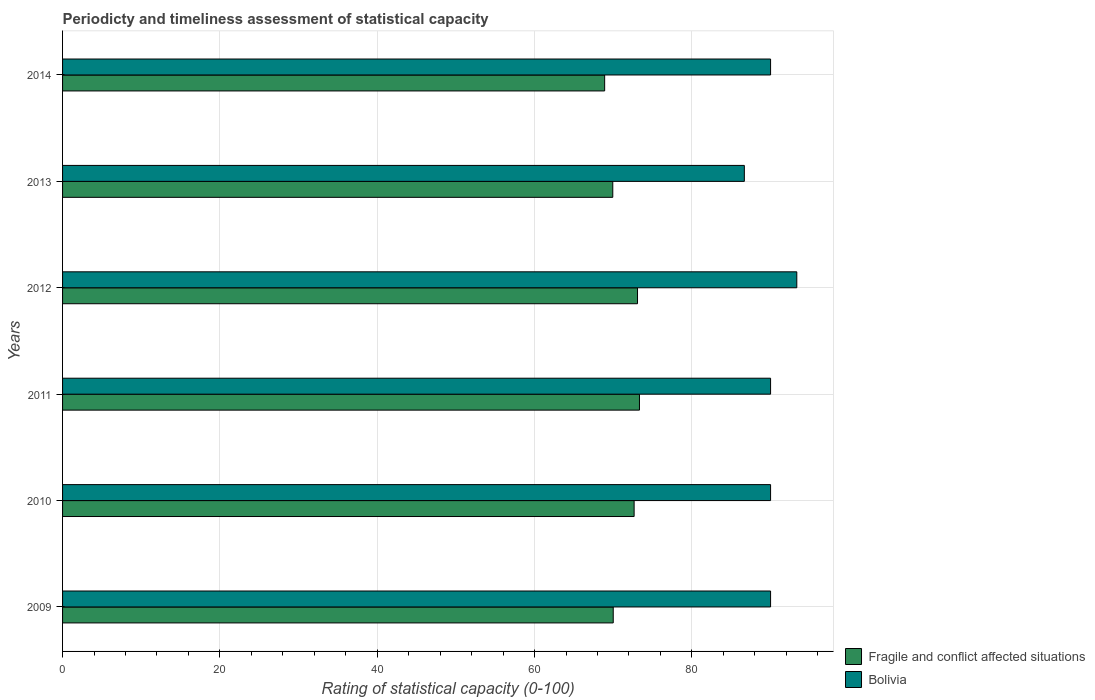How many different coloured bars are there?
Offer a terse response. 2. How many bars are there on the 5th tick from the top?
Offer a terse response. 2. What is the label of the 4th group of bars from the top?
Your response must be concise. 2011. What is the rating of statistical capacity in Fragile and conflict affected situations in 2012?
Provide a succinct answer. 73.09. Across all years, what is the maximum rating of statistical capacity in Fragile and conflict affected situations?
Offer a very short reply. 73.33. Across all years, what is the minimum rating of statistical capacity in Bolivia?
Provide a short and direct response. 86.67. What is the total rating of statistical capacity in Fragile and conflict affected situations in the graph?
Offer a very short reply. 427.92. What is the difference between the rating of statistical capacity in Bolivia in 2010 and that in 2011?
Your answer should be very brief. 0. What is the difference between the rating of statistical capacity in Bolivia in 2009 and the rating of statistical capacity in Fragile and conflict affected situations in 2014?
Offer a very short reply. 21.09. What is the average rating of statistical capacity in Bolivia per year?
Your answer should be compact. 90. In the year 2014, what is the difference between the rating of statistical capacity in Bolivia and rating of statistical capacity in Fragile and conflict affected situations?
Provide a succinct answer. 21.09. What is the ratio of the rating of statistical capacity in Fragile and conflict affected situations in 2013 to that in 2014?
Your answer should be compact. 1.02. What is the difference between the highest and the second highest rating of statistical capacity in Bolivia?
Your answer should be compact. 3.33. What is the difference between the highest and the lowest rating of statistical capacity in Bolivia?
Provide a short and direct response. 6.67. In how many years, is the rating of statistical capacity in Fragile and conflict affected situations greater than the average rating of statistical capacity in Fragile and conflict affected situations taken over all years?
Keep it short and to the point. 3. Is the sum of the rating of statistical capacity in Bolivia in 2010 and 2014 greater than the maximum rating of statistical capacity in Fragile and conflict affected situations across all years?
Your response must be concise. Yes. What does the 2nd bar from the top in 2010 represents?
Keep it short and to the point. Fragile and conflict affected situations. Are all the bars in the graph horizontal?
Offer a terse response. Yes. How many years are there in the graph?
Your response must be concise. 6. Does the graph contain any zero values?
Offer a very short reply. No. Where does the legend appear in the graph?
Your answer should be compact. Bottom right. How many legend labels are there?
Your response must be concise. 2. How are the legend labels stacked?
Your answer should be compact. Vertical. What is the title of the graph?
Offer a very short reply. Periodicty and timeliness assessment of statistical capacity. What is the label or title of the X-axis?
Your answer should be compact. Rating of statistical capacity (0-100). What is the label or title of the Y-axis?
Provide a short and direct response. Years. What is the Rating of statistical capacity (0-100) in Fragile and conflict affected situations in 2009?
Give a very brief answer. 70. What is the Rating of statistical capacity (0-100) in Bolivia in 2009?
Keep it short and to the point. 90. What is the Rating of statistical capacity (0-100) of Fragile and conflict affected situations in 2010?
Offer a terse response. 72.65. What is the Rating of statistical capacity (0-100) in Bolivia in 2010?
Make the answer very short. 90. What is the Rating of statistical capacity (0-100) in Fragile and conflict affected situations in 2011?
Your response must be concise. 73.33. What is the Rating of statistical capacity (0-100) of Bolivia in 2011?
Keep it short and to the point. 90. What is the Rating of statistical capacity (0-100) in Fragile and conflict affected situations in 2012?
Provide a succinct answer. 73.09. What is the Rating of statistical capacity (0-100) in Bolivia in 2012?
Keep it short and to the point. 93.33. What is the Rating of statistical capacity (0-100) in Fragile and conflict affected situations in 2013?
Offer a terse response. 69.94. What is the Rating of statistical capacity (0-100) in Bolivia in 2013?
Your response must be concise. 86.67. What is the Rating of statistical capacity (0-100) in Fragile and conflict affected situations in 2014?
Provide a succinct answer. 68.91. Across all years, what is the maximum Rating of statistical capacity (0-100) of Fragile and conflict affected situations?
Provide a succinct answer. 73.33. Across all years, what is the maximum Rating of statistical capacity (0-100) in Bolivia?
Provide a succinct answer. 93.33. Across all years, what is the minimum Rating of statistical capacity (0-100) in Fragile and conflict affected situations?
Keep it short and to the point. 68.91. Across all years, what is the minimum Rating of statistical capacity (0-100) of Bolivia?
Provide a short and direct response. 86.67. What is the total Rating of statistical capacity (0-100) in Fragile and conflict affected situations in the graph?
Provide a short and direct response. 427.92. What is the total Rating of statistical capacity (0-100) in Bolivia in the graph?
Your answer should be very brief. 540. What is the difference between the Rating of statistical capacity (0-100) in Fragile and conflict affected situations in 2009 and that in 2010?
Provide a succinct answer. -2.65. What is the difference between the Rating of statistical capacity (0-100) of Bolivia in 2009 and that in 2010?
Make the answer very short. 0. What is the difference between the Rating of statistical capacity (0-100) of Fragile and conflict affected situations in 2009 and that in 2012?
Your response must be concise. -3.09. What is the difference between the Rating of statistical capacity (0-100) in Fragile and conflict affected situations in 2009 and that in 2013?
Your answer should be very brief. 0.06. What is the difference between the Rating of statistical capacity (0-100) in Bolivia in 2009 and that in 2013?
Offer a very short reply. 3.33. What is the difference between the Rating of statistical capacity (0-100) of Fragile and conflict affected situations in 2009 and that in 2014?
Keep it short and to the point. 1.09. What is the difference between the Rating of statistical capacity (0-100) of Bolivia in 2009 and that in 2014?
Make the answer very short. 0. What is the difference between the Rating of statistical capacity (0-100) of Fragile and conflict affected situations in 2010 and that in 2011?
Give a very brief answer. -0.68. What is the difference between the Rating of statistical capacity (0-100) in Bolivia in 2010 and that in 2011?
Your response must be concise. 0. What is the difference between the Rating of statistical capacity (0-100) of Fragile and conflict affected situations in 2010 and that in 2012?
Keep it short and to the point. -0.43. What is the difference between the Rating of statistical capacity (0-100) of Fragile and conflict affected situations in 2010 and that in 2013?
Your answer should be very brief. 2.71. What is the difference between the Rating of statistical capacity (0-100) of Fragile and conflict affected situations in 2010 and that in 2014?
Offer a very short reply. 3.75. What is the difference between the Rating of statistical capacity (0-100) of Fragile and conflict affected situations in 2011 and that in 2012?
Your response must be concise. 0.25. What is the difference between the Rating of statistical capacity (0-100) of Bolivia in 2011 and that in 2012?
Make the answer very short. -3.33. What is the difference between the Rating of statistical capacity (0-100) of Fragile and conflict affected situations in 2011 and that in 2013?
Make the answer very short. 3.39. What is the difference between the Rating of statistical capacity (0-100) in Bolivia in 2011 and that in 2013?
Your answer should be very brief. 3.33. What is the difference between the Rating of statistical capacity (0-100) in Fragile and conflict affected situations in 2011 and that in 2014?
Keep it short and to the point. 4.43. What is the difference between the Rating of statistical capacity (0-100) in Fragile and conflict affected situations in 2012 and that in 2013?
Provide a succinct answer. 3.14. What is the difference between the Rating of statistical capacity (0-100) in Bolivia in 2012 and that in 2013?
Ensure brevity in your answer.  6.67. What is the difference between the Rating of statistical capacity (0-100) of Fragile and conflict affected situations in 2012 and that in 2014?
Make the answer very short. 4.18. What is the difference between the Rating of statistical capacity (0-100) in Bolivia in 2012 and that in 2014?
Your answer should be compact. 3.33. What is the difference between the Rating of statistical capacity (0-100) in Fragile and conflict affected situations in 2013 and that in 2014?
Offer a very short reply. 1.03. What is the difference between the Rating of statistical capacity (0-100) in Fragile and conflict affected situations in 2009 and the Rating of statistical capacity (0-100) in Bolivia in 2010?
Provide a short and direct response. -20. What is the difference between the Rating of statistical capacity (0-100) in Fragile and conflict affected situations in 2009 and the Rating of statistical capacity (0-100) in Bolivia in 2012?
Keep it short and to the point. -23.33. What is the difference between the Rating of statistical capacity (0-100) in Fragile and conflict affected situations in 2009 and the Rating of statistical capacity (0-100) in Bolivia in 2013?
Provide a succinct answer. -16.67. What is the difference between the Rating of statistical capacity (0-100) of Fragile and conflict affected situations in 2009 and the Rating of statistical capacity (0-100) of Bolivia in 2014?
Keep it short and to the point. -20. What is the difference between the Rating of statistical capacity (0-100) of Fragile and conflict affected situations in 2010 and the Rating of statistical capacity (0-100) of Bolivia in 2011?
Provide a short and direct response. -17.35. What is the difference between the Rating of statistical capacity (0-100) in Fragile and conflict affected situations in 2010 and the Rating of statistical capacity (0-100) in Bolivia in 2012?
Your response must be concise. -20.68. What is the difference between the Rating of statistical capacity (0-100) in Fragile and conflict affected situations in 2010 and the Rating of statistical capacity (0-100) in Bolivia in 2013?
Keep it short and to the point. -14.01. What is the difference between the Rating of statistical capacity (0-100) of Fragile and conflict affected situations in 2010 and the Rating of statistical capacity (0-100) of Bolivia in 2014?
Your answer should be very brief. -17.35. What is the difference between the Rating of statistical capacity (0-100) of Fragile and conflict affected situations in 2011 and the Rating of statistical capacity (0-100) of Bolivia in 2013?
Your answer should be very brief. -13.33. What is the difference between the Rating of statistical capacity (0-100) of Fragile and conflict affected situations in 2011 and the Rating of statistical capacity (0-100) of Bolivia in 2014?
Provide a succinct answer. -16.67. What is the difference between the Rating of statistical capacity (0-100) of Fragile and conflict affected situations in 2012 and the Rating of statistical capacity (0-100) of Bolivia in 2013?
Provide a short and direct response. -13.58. What is the difference between the Rating of statistical capacity (0-100) in Fragile and conflict affected situations in 2012 and the Rating of statistical capacity (0-100) in Bolivia in 2014?
Make the answer very short. -16.91. What is the difference between the Rating of statistical capacity (0-100) of Fragile and conflict affected situations in 2013 and the Rating of statistical capacity (0-100) of Bolivia in 2014?
Keep it short and to the point. -20.06. What is the average Rating of statistical capacity (0-100) of Fragile and conflict affected situations per year?
Offer a terse response. 71.32. In the year 2009, what is the difference between the Rating of statistical capacity (0-100) in Fragile and conflict affected situations and Rating of statistical capacity (0-100) in Bolivia?
Make the answer very short. -20. In the year 2010, what is the difference between the Rating of statistical capacity (0-100) of Fragile and conflict affected situations and Rating of statistical capacity (0-100) of Bolivia?
Ensure brevity in your answer.  -17.35. In the year 2011, what is the difference between the Rating of statistical capacity (0-100) of Fragile and conflict affected situations and Rating of statistical capacity (0-100) of Bolivia?
Your answer should be compact. -16.67. In the year 2012, what is the difference between the Rating of statistical capacity (0-100) in Fragile and conflict affected situations and Rating of statistical capacity (0-100) in Bolivia?
Ensure brevity in your answer.  -20.25. In the year 2013, what is the difference between the Rating of statistical capacity (0-100) in Fragile and conflict affected situations and Rating of statistical capacity (0-100) in Bolivia?
Give a very brief answer. -16.72. In the year 2014, what is the difference between the Rating of statistical capacity (0-100) of Fragile and conflict affected situations and Rating of statistical capacity (0-100) of Bolivia?
Offer a terse response. -21.09. What is the ratio of the Rating of statistical capacity (0-100) in Fragile and conflict affected situations in 2009 to that in 2010?
Your response must be concise. 0.96. What is the ratio of the Rating of statistical capacity (0-100) of Bolivia in 2009 to that in 2010?
Your response must be concise. 1. What is the ratio of the Rating of statistical capacity (0-100) of Fragile and conflict affected situations in 2009 to that in 2011?
Your response must be concise. 0.95. What is the ratio of the Rating of statistical capacity (0-100) of Fragile and conflict affected situations in 2009 to that in 2012?
Keep it short and to the point. 0.96. What is the ratio of the Rating of statistical capacity (0-100) in Bolivia in 2009 to that in 2012?
Give a very brief answer. 0.96. What is the ratio of the Rating of statistical capacity (0-100) in Fragile and conflict affected situations in 2009 to that in 2014?
Your response must be concise. 1.02. What is the ratio of the Rating of statistical capacity (0-100) in Bolivia in 2009 to that in 2014?
Offer a terse response. 1. What is the ratio of the Rating of statistical capacity (0-100) of Fragile and conflict affected situations in 2010 to that in 2011?
Keep it short and to the point. 0.99. What is the ratio of the Rating of statistical capacity (0-100) in Bolivia in 2010 to that in 2012?
Your answer should be compact. 0.96. What is the ratio of the Rating of statistical capacity (0-100) of Fragile and conflict affected situations in 2010 to that in 2013?
Your response must be concise. 1.04. What is the ratio of the Rating of statistical capacity (0-100) of Bolivia in 2010 to that in 2013?
Make the answer very short. 1.04. What is the ratio of the Rating of statistical capacity (0-100) of Fragile and conflict affected situations in 2010 to that in 2014?
Give a very brief answer. 1.05. What is the ratio of the Rating of statistical capacity (0-100) in Bolivia in 2010 to that in 2014?
Offer a terse response. 1. What is the ratio of the Rating of statistical capacity (0-100) in Fragile and conflict affected situations in 2011 to that in 2012?
Your answer should be compact. 1. What is the ratio of the Rating of statistical capacity (0-100) of Bolivia in 2011 to that in 2012?
Provide a succinct answer. 0.96. What is the ratio of the Rating of statistical capacity (0-100) of Fragile and conflict affected situations in 2011 to that in 2013?
Provide a short and direct response. 1.05. What is the ratio of the Rating of statistical capacity (0-100) in Fragile and conflict affected situations in 2011 to that in 2014?
Offer a very short reply. 1.06. What is the ratio of the Rating of statistical capacity (0-100) in Bolivia in 2011 to that in 2014?
Offer a terse response. 1. What is the ratio of the Rating of statistical capacity (0-100) in Fragile and conflict affected situations in 2012 to that in 2013?
Ensure brevity in your answer.  1.04. What is the ratio of the Rating of statistical capacity (0-100) in Fragile and conflict affected situations in 2012 to that in 2014?
Provide a succinct answer. 1.06. What is the ratio of the Rating of statistical capacity (0-100) in Bolivia in 2012 to that in 2014?
Provide a succinct answer. 1.04. What is the ratio of the Rating of statistical capacity (0-100) of Fragile and conflict affected situations in 2013 to that in 2014?
Your answer should be very brief. 1.01. What is the ratio of the Rating of statistical capacity (0-100) of Bolivia in 2013 to that in 2014?
Keep it short and to the point. 0.96. What is the difference between the highest and the second highest Rating of statistical capacity (0-100) in Fragile and conflict affected situations?
Provide a succinct answer. 0.25. What is the difference between the highest and the second highest Rating of statistical capacity (0-100) in Bolivia?
Your response must be concise. 3.33. What is the difference between the highest and the lowest Rating of statistical capacity (0-100) of Fragile and conflict affected situations?
Your answer should be compact. 4.43. 